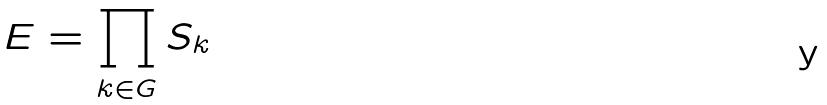Convert formula to latex. <formula><loc_0><loc_0><loc_500><loc_500>E = \prod _ { k \in G } S _ { k }</formula> 